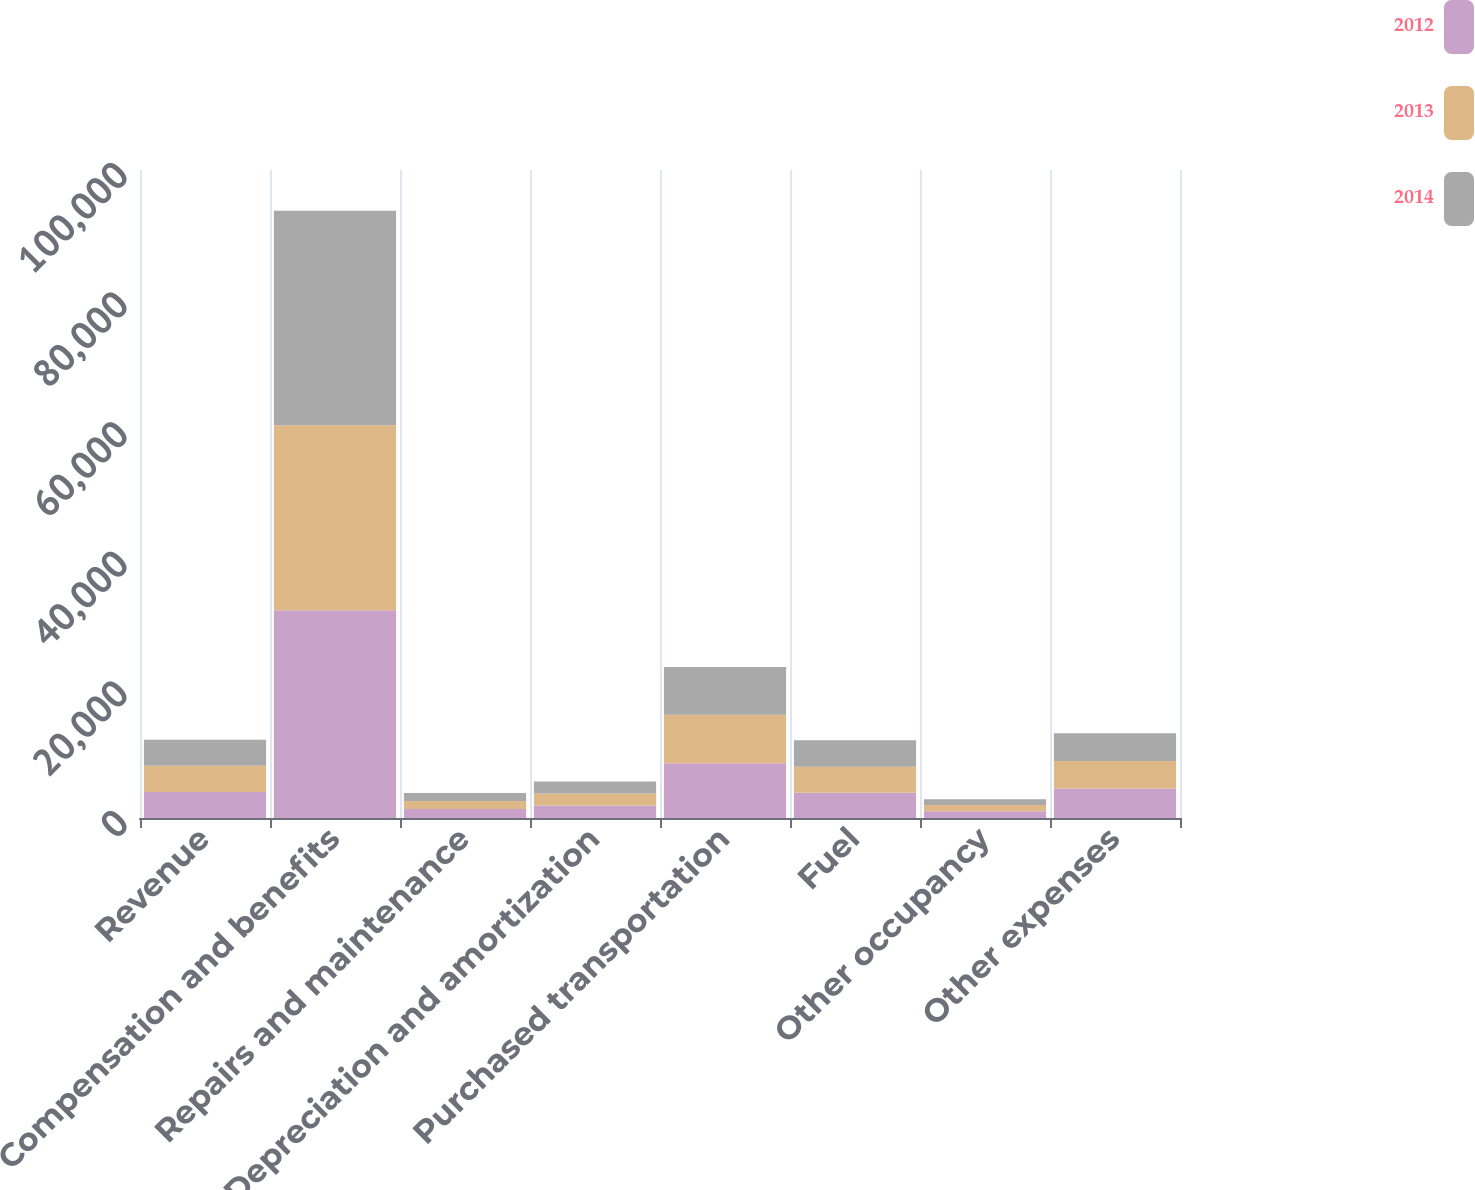Convert chart. <chart><loc_0><loc_0><loc_500><loc_500><stacked_bar_chart><ecel><fcel>Revenue<fcel>Compensation and benefits<fcel>Repairs and maintenance<fcel>Depreciation and amortization<fcel>Purchased transportation<fcel>Fuel<fcel>Other occupancy<fcel>Other expenses<nl><fcel>2012<fcel>4027<fcel>32045<fcel>1371<fcel>1923<fcel>8460<fcel>3883<fcel>1044<fcel>4538<nl><fcel>2013<fcel>4027<fcel>28557<fcel>1240<fcel>1867<fcel>7486<fcel>4027<fcel>950<fcel>4277<nl><fcel>2014<fcel>4027<fcel>33102<fcel>1228<fcel>1858<fcel>7354<fcel>4090<fcel>902<fcel>4250<nl></chart> 